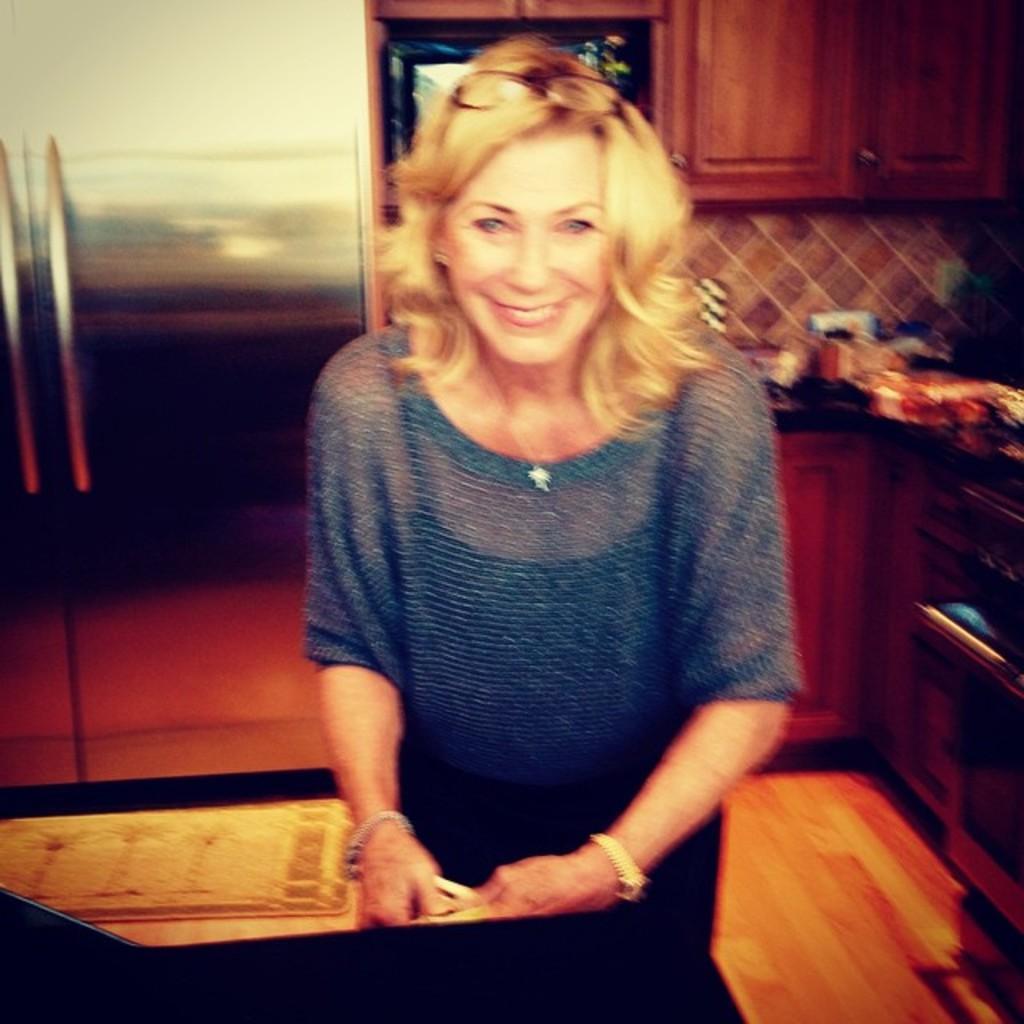Please provide a concise description of this image. In the foreground of this picture, there is a woman standing and smiling. In the background, there is a refrigerator, few cupboards, microwave oven, few objects on the kitchen slab and the floor. 